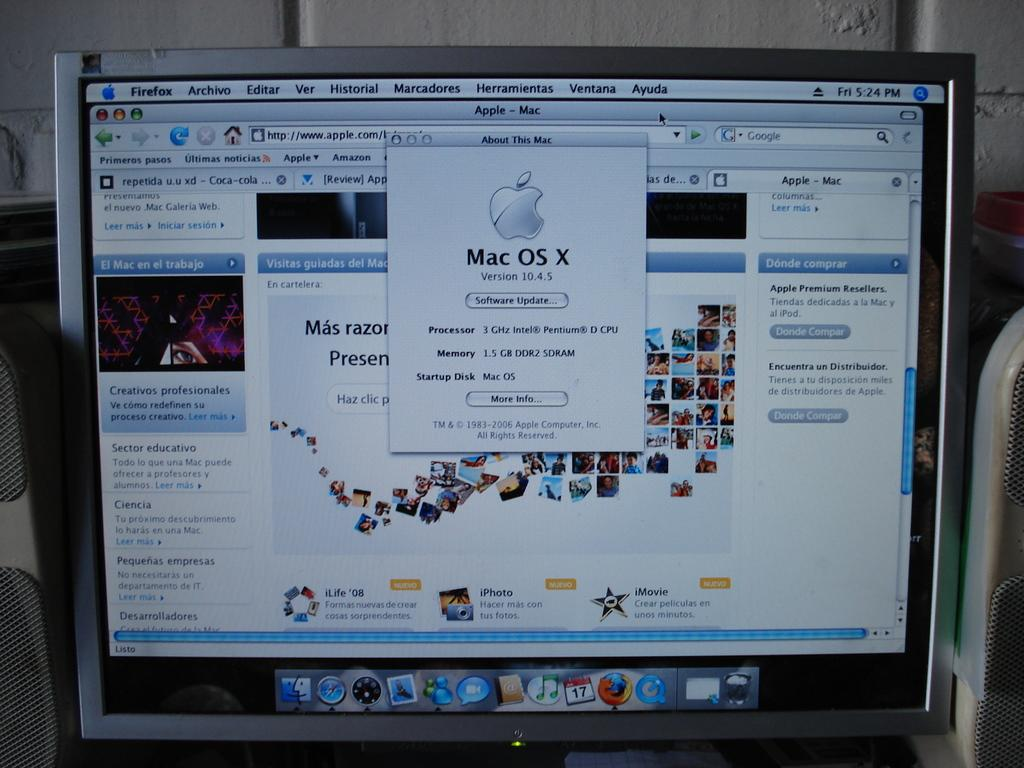Provide a one-sentence caption for the provided image. Mac computer showing a Apple Mac Software Update screen. 